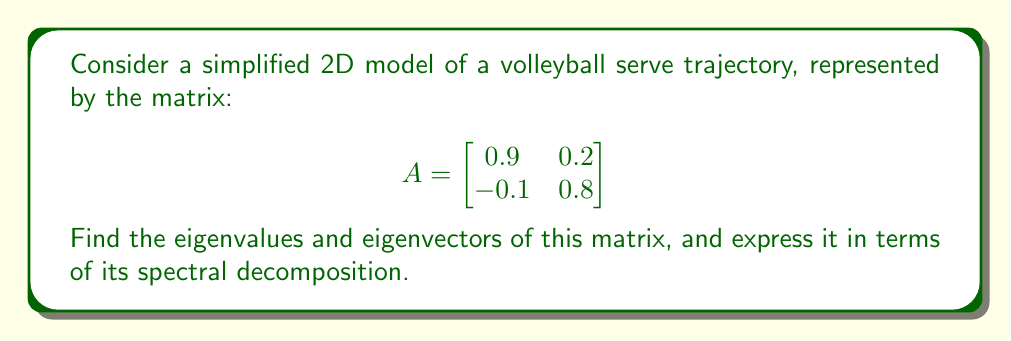Show me your answer to this math problem. 1) To find the eigenvalues, we solve the characteristic equation:
   $$\det(A - \lambda I) = 0$$
   
   $$\begin{vmatrix}
   0.9 - \lambda & 0.2 \\
   -0.1 & 0.8 - \lambda
   \end{vmatrix} = 0$$

   $$(0.9 - \lambda)(0.8 - \lambda) + 0.02 = 0$$
   
   $$\lambda^2 - 1.7\lambda + 0.74 = 0$$

2) Solving this quadratic equation:
   $$\lambda = \frac{1.7 \pm \sqrt{1.7^2 - 4(0.74)}}{2} = \frac{1.7 \pm \sqrt{1.13}}{2}$$

   $$\lambda_1 = 1, \lambda_2 = 0.7$$

3) For each eigenvalue, we find the corresponding eigenvector:

   For $\lambda_1 = 1$:
   $$(A - I)v_1 = 0$$
   $$\begin{bmatrix}
   -0.1 & 0.2 \\
   -0.1 & -0.2
   \end{bmatrix}\begin{bmatrix}
   x \\
   y
   \end{bmatrix} = \begin{bmatrix}
   0 \\
   0
   \end{bmatrix}$$

   This gives us: $v_1 = \begin{bmatrix} 2 \\ 1 \end{bmatrix}$

   For $\lambda_2 = 0.7$:
   $$(A - 0.7I)v_2 = 0$$
   $$\begin{bmatrix}
   0.2 & 0.2 \\
   -0.1 & 0.1
   \end{bmatrix}\begin{bmatrix}
   x \\
   y
   \end{bmatrix} = \begin{bmatrix}
   0 \\
   0
   \end{bmatrix}$$

   This gives us: $v_2 = \begin{bmatrix} -1 \\ 1 \end{bmatrix}$

4) The spectral decomposition is given by:
   $$A = P\Lambda P^{-1}$$

   Where $P$ is the matrix of eigenvectors and $\Lambda$ is the diagonal matrix of eigenvalues:

   $$P = \begin{bmatrix}
   2 & -1 \\
   1 & 1
   \end{bmatrix}$$

   $$\Lambda = \begin{bmatrix}
   1 & 0 \\
   0 & 0.7
   \end{bmatrix}$$

   $$P^{-1} = \frac{1}{3}\begin{bmatrix}
   1 & 1 \\
   -1 & 2
   \end{bmatrix}$$

5) Therefore, the spectral decomposition is:

   $$A = \begin{bmatrix}
   2 & -1 \\
   1 & 1
   \end{bmatrix}
   \begin{bmatrix}
   1 & 0 \\
   0 & 0.7
   \end{bmatrix}
   \frac{1}{3}\begin{bmatrix}
   1 & 1 \\
   -1 & 2
   \end{bmatrix}$$
Answer: $A = \begin{bmatrix}
2 & -1 \\
1 & 1
\end{bmatrix}
\begin{bmatrix}
1 & 0 \\
0 & 0.7
\end{bmatrix}
\frac{1}{3}\begin{bmatrix}
1 & 1 \\
-1 & 2
\end{bmatrix}$ 